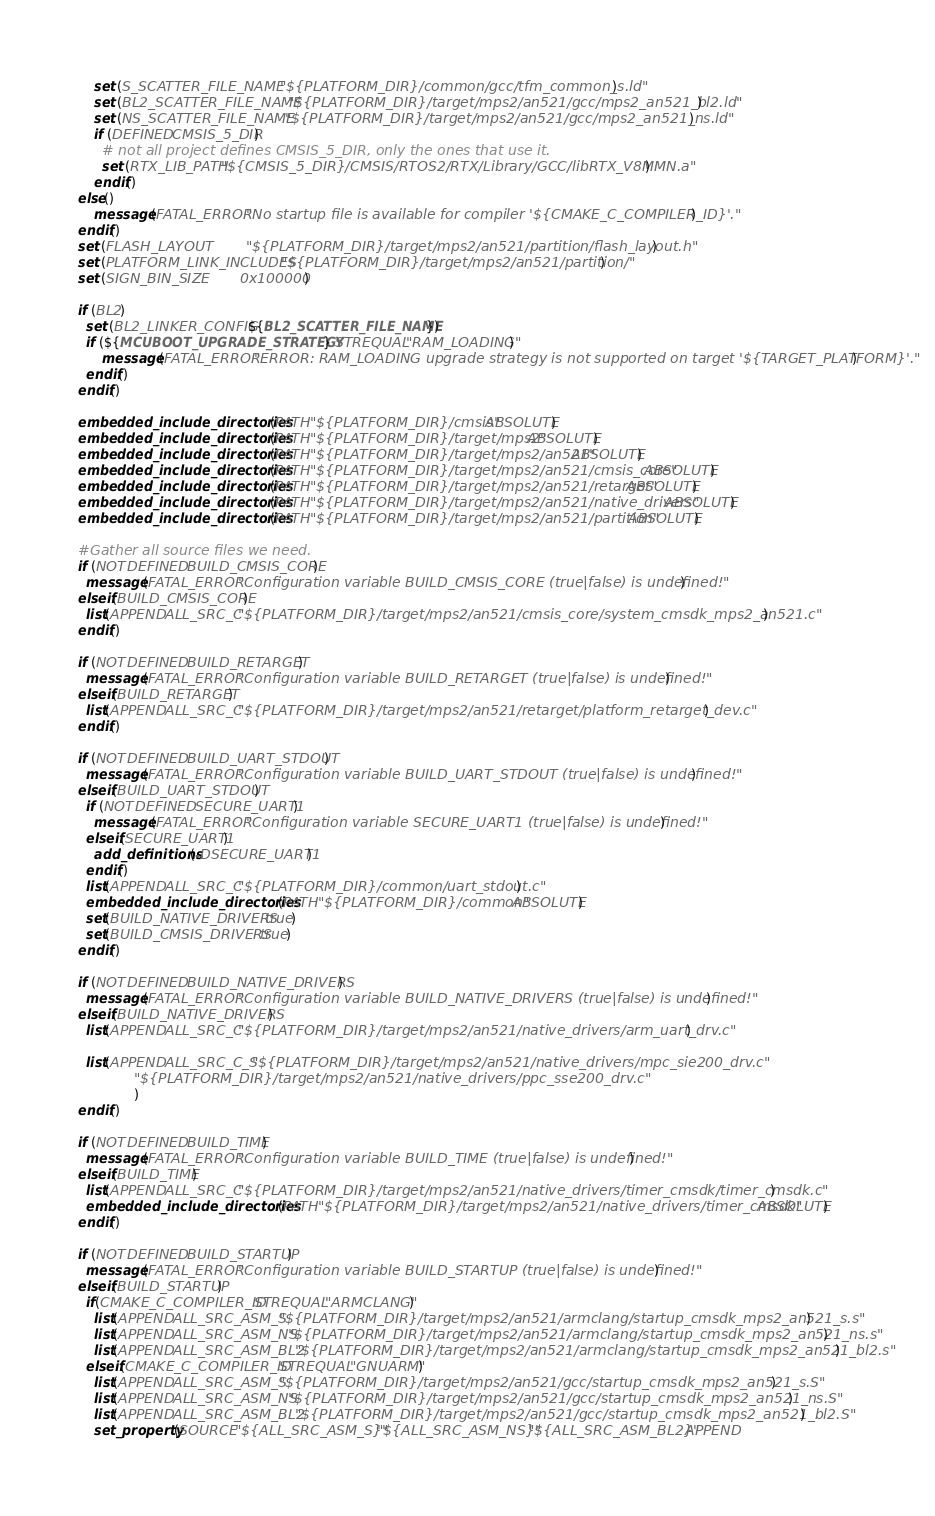Convert code to text. <code><loc_0><loc_0><loc_500><loc_500><_CMake_>    set (S_SCATTER_FILE_NAME   "${PLATFORM_DIR}/common/gcc/tfm_common_s.ld")
    set (BL2_SCATTER_FILE_NAME "${PLATFORM_DIR}/target/mps2/an521/gcc/mps2_an521_bl2.ld")
    set (NS_SCATTER_FILE_NAME  "${PLATFORM_DIR}/target/mps2/an521/gcc/mps2_an521_ns.ld")
    if (DEFINED CMSIS_5_DIR)
      # not all project defines CMSIS_5_DIR, only the ones that use it.
      set (RTX_LIB_PATH "${CMSIS_5_DIR}/CMSIS/RTOS2/RTX/Library/GCC/libRTX_V8MMN.a")
    endif()
else()
    message(FATAL_ERROR "No startup file is available for compiler '${CMAKE_C_COMPILER_ID}'.")
endif()
set (FLASH_LAYOUT           "${PLATFORM_DIR}/target/mps2/an521/partition/flash_layout.h")
set (PLATFORM_LINK_INCLUDES "${PLATFORM_DIR}/target/mps2/an521/partition/")
set (SIGN_BIN_SIZE          0x100000)

if (BL2)
  set (BL2_LINKER_CONFIG ${BL2_SCATTER_FILE_NAME})
  if (${MCUBOOT_UPGRADE_STRATEGY} STREQUAL "RAM_LOADING")
      message(FATAL_ERROR "ERROR: RAM_LOADING upgrade strategy is not supported on target '${TARGET_PLATFORM}'.")
  endif()
endif()

embedded_include_directories(PATH "${PLATFORM_DIR}/cmsis" ABSOLUTE)
embedded_include_directories(PATH "${PLATFORM_DIR}/target/mps2" ABSOLUTE)
embedded_include_directories(PATH "${PLATFORM_DIR}/target/mps2/an521" ABSOLUTE)
embedded_include_directories(PATH "${PLATFORM_DIR}/target/mps2/an521/cmsis_core" ABSOLUTE)
embedded_include_directories(PATH "${PLATFORM_DIR}/target/mps2/an521/retarget" ABSOLUTE)
embedded_include_directories(PATH "${PLATFORM_DIR}/target/mps2/an521/native_drivers" ABSOLUTE)
embedded_include_directories(PATH "${PLATFORM_DIR}/target/mps2/an521/partition" ABSOLUTE)

#Gather all source files we need.
if (NOT DEFINED BUILD_CMSIS_CORE)
  message(FATAL_ERROR "Configuration variable BUILD_CMSIS_CORE (true|false) is undefined!")
elseif(BUILD_CMSIS_CORE)
  list(APPEND ALL_SRC_C "${PLATFORM_DIR}/target/mps2/an521/cmsis_core/system_cmsdk_mps2_an521.c")
endif()

if (NOT DEFINED BUILD_RETARGET)
  message(FATAL_ERROR "Configuration variable BUILD_RETARGET (true|false) is undefined!")
elseif(BUILD_RETARGET)
  list(APPEND ALL_SRC_C "${PLATFORM_DIR}/target/mps2/an521/retarget/platform_retarget_dev.c")
endif()

if (NOT DEFINED BUILD_UART_STDOUT)
  message(FATAL_ERROR "Configuration variable BUILD_UART_STDOUT (true|false) is undefined!")
elseif(BUILD_UART_STDOUT)
  if (NOT DEFINED SECURE_UART1)
    message(FATAL_ERROR "Configuration variable SECURE_UART1 (true|false) is undefined!")
  elseif(SECURE_UART1)
    add_definitions(-DSECURE_UART1)
  endif()
  list(APPEND ALL_SRC_C "${PLATFORM_DIR}/common/uart_stdout.c")
  embedded_include_directories(PATH "${PLATFORM_DIR}/common" ABSOLUTE)
  set(BUILD_NATIVE_DRIVERS true)
  set(BUILD_CMSIS_DRIVERS true)
endif()

if (NOT DEFINED BUILD_NATIVE_DRIVERS)
  message(FATAL_ERROR "Configuration variable BUILD_NATIVE_DRIVERS (true|false) is undefined!")
elseif(BUILD_NATIVE_DRIVERS)
  list(APPEND ALL_SRC_C "${PLATFORM_DIR}/target/mps2/an521/native_drivers/arm_uart_drv.c")

  list(APPEND ALL_SRC_C_S "${PLATFORM_DIR}/target/mps2/an521/native_drivers/mpc_sie200_drv.c"
              "${PLATFORM_DIR}/target/mps2/an521/native_drivers/ppc_sse200_drv.c"
              )
endif()

if (NOT DEFINED BUILD_TIME)
  message(FATAL_ERROR "Configuration variable BUILD_TIME (true|false) is undefined!")
elseif(BUILD_TIME)
  list(APPEND ALL_SRC_C "${PLATFORM_DIR}/target/mps2/an521/native_drivers/timer_cmsdk/timer_cmsdk.c")
  embedded_include_directories(PATH "${PLATFORM_DIR}/target/mps2/an521/native_drivers/timer_cmsdk" ABSOLUTE)
endif()

if (NOT DEFINED BUILD_STARTUP)
  message(FATAL_ERROR "Configuration variable BUILD_STARTUP (true|false) is undefined!")
elseif(BUILD_STARTUP)
  if(CMAKE_C_COMPILER_ID STREQUAL "ARMCLANG")
    list(APPEND ALL_SRC_ASM_S "${PLATFORM_DIR}/target/mps2/an521/armclang/startup_cmsdk_mps2_an521_s.s")
    list(APPEND ALL_SRC_ASM_NS "${PLATFORM_DIR}/target/mps2/an521/armclang/startup_cmsdk_mps2_an521_ns.s")
    list(APPEND ALL_SRC_ASM_BL2 "${PLATFORM_DIR}/target/mps2/an521/armclang/startup_cmsdk_mps2_an521_bl2.s")
  elseif(CMAKE_C_COMPILER_ID STREQUAL "GNUARM")
    list(APPEND ALL_SRC_ASM_S "${PLATFORM_DIR}/target/mps2/an521/gcc/startup_cmsdk_mps2_an521_s.S")
    list(APPEND ALL_SRC_ASM_NS "${PLATFORM_DIR}/target/mps2/an521/gcc/startup_cmsdk_mps2_an521_ns.S")
    list(APPEND ALL_SRC_ASM_BL2 "${PLATFORM_DIR}/target/mps2/an521/gcc/startup_cmsdk_mps2_an521_bl2.S")
    set_property(SOURCE "${ALL_SRC_ASM_S}" "${ALL_SRC_ASM_NS}" "${ALL_SRC_ASM_BL2}" APPEND</code> 